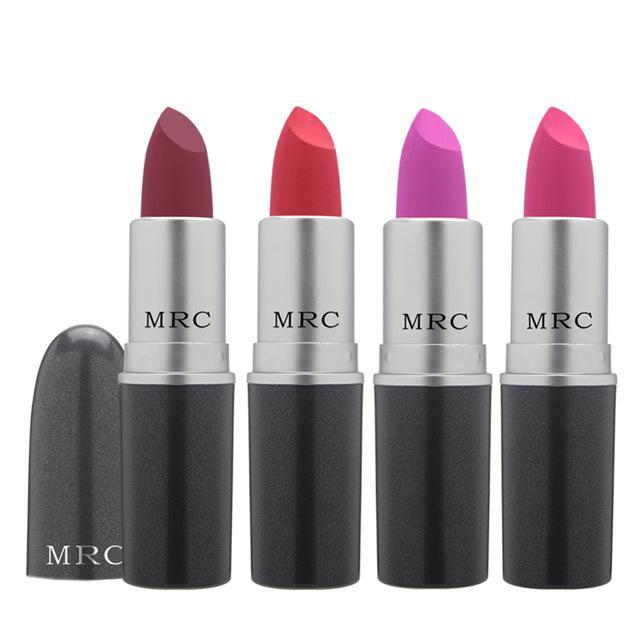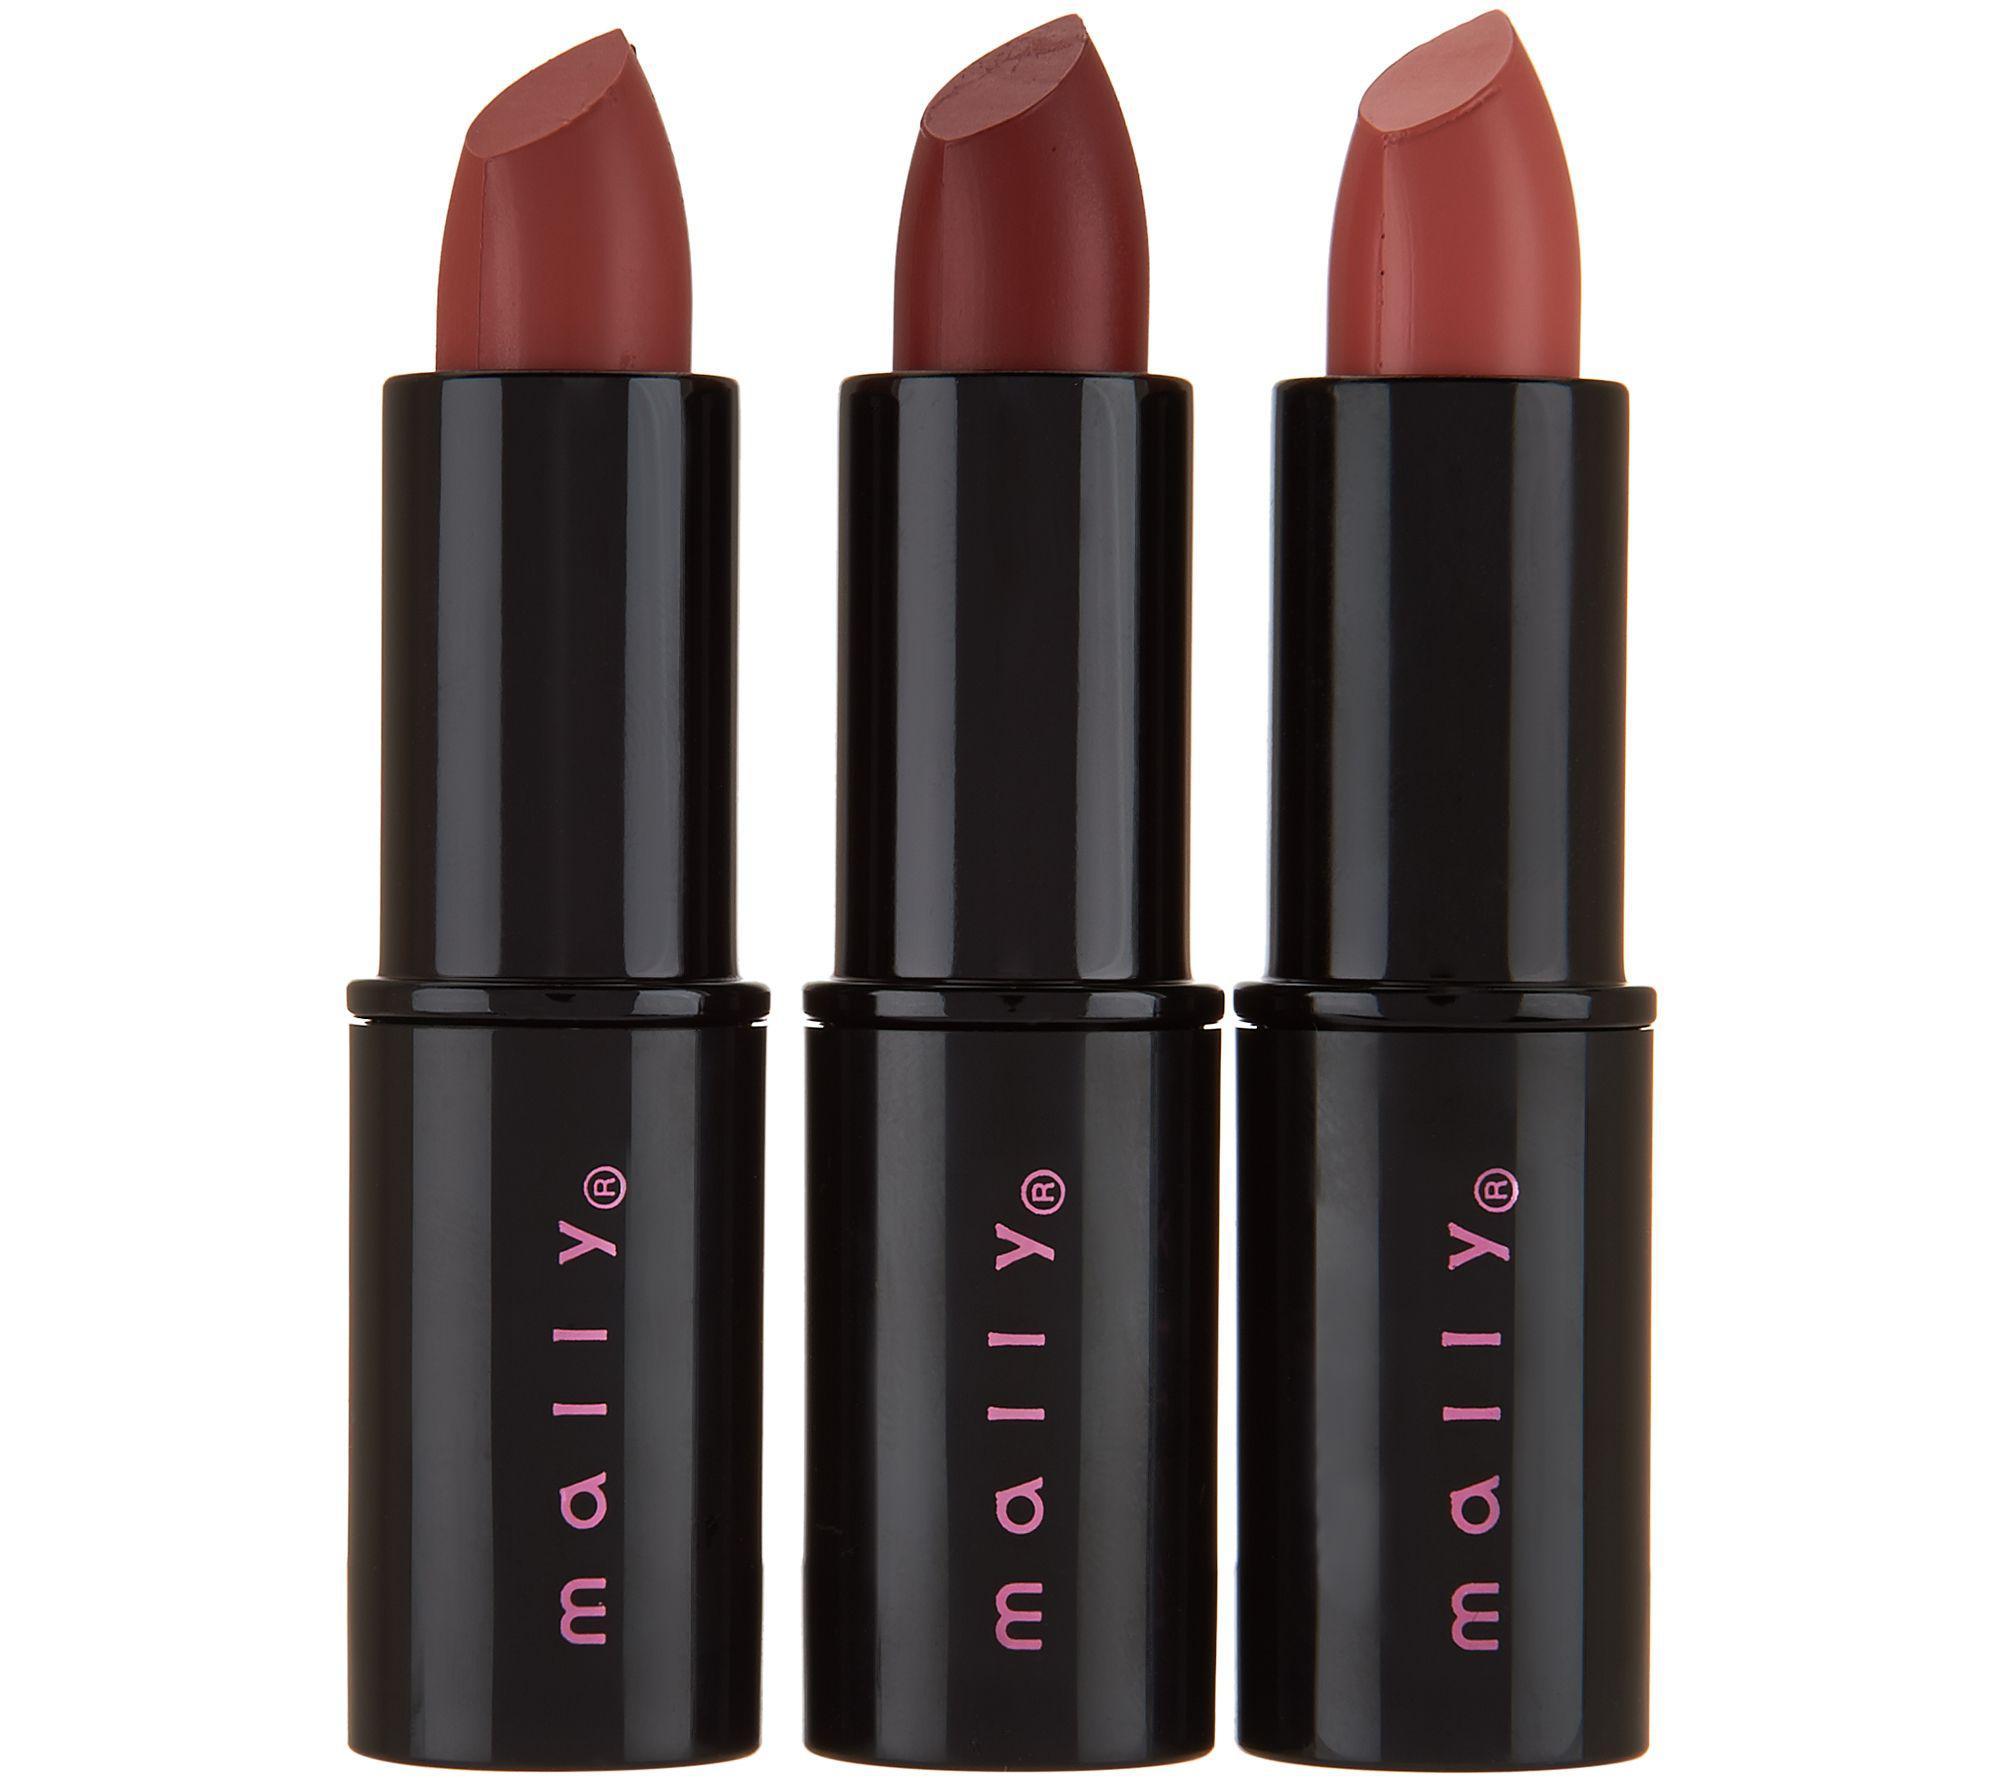The first image is the image on the left, the second image is the image on the right. For the images shown, is this caption "Only one lipstick cap is shown right next to a lipstick." true? Answer yes or no. Yes. The first image is the image on the left, the second image is the image on the right. Considering the images on both sides, is "An image with three lip cosmetics includes at least one product shaped like a crayon." valid? Answer yes or no. No. 